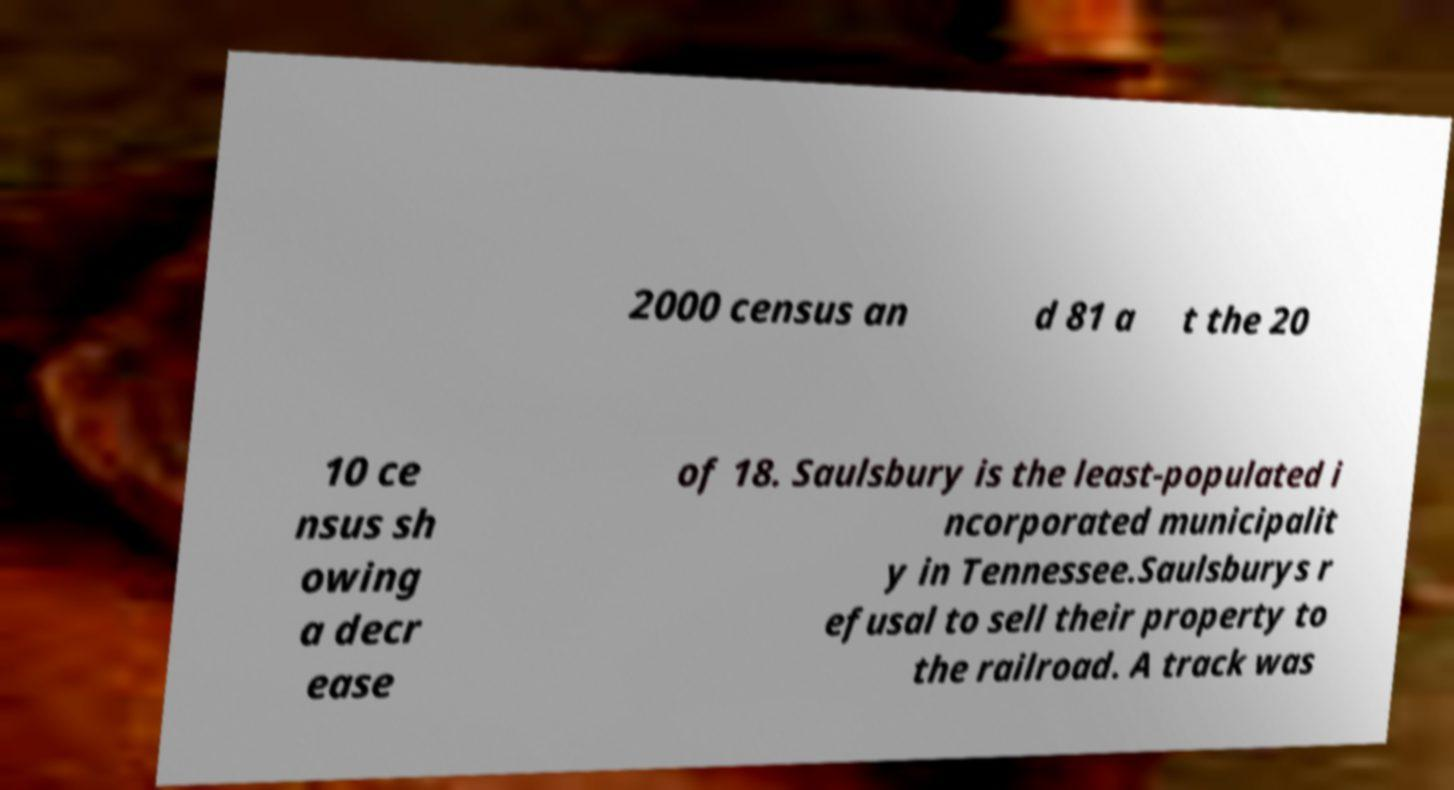What messages or text are displayed in this image? I need them in a readable, typed format. 2000 census an d 81 a t the 20 10 ce nsus sh owing a decr ease of 18. Saulsbury is the least-populated i ncorporated municipalit y in Tennessee.Saulsburys r efusal to sell their property to the railroad. A track was 